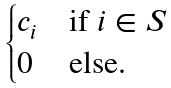Convert formula to latex. <formula><loc_0><loc_0><loc_500><loc_500>\begin{cases} c _ { i } & \text {if } i \in S \\ 0 & \text {else.} \end{cases}</formula> 